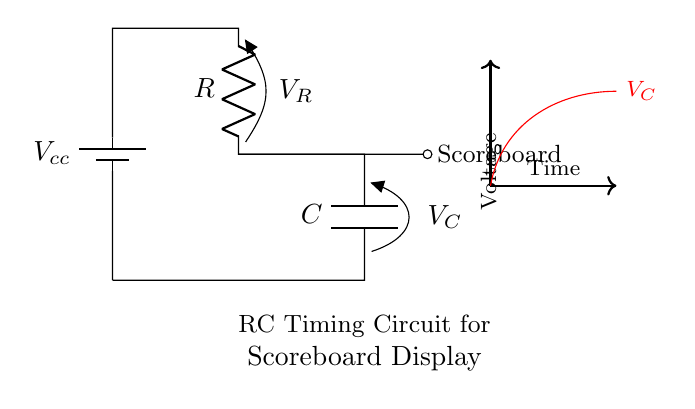What is the power supply voltage? The power supply voltage, denoted as Vcc, is usually specified alongside the battery symbol in the circuit. It represents the voltage supplied to the circuit components, ensuring proper functioning.
Answer: Vcc What components are present in the circuit? The circuit includes a battery, a resistor labeled R, and a capacitor labeled C. These components are fundamental in an RC timing circuit, which shapes the signal timing.
Answer: Battery, resistor, capacitor What is the purpose of the resistor in this circuit? The resistor in an RC timing circuit controls the charging and discharging rate of the capacitor. By placing resistance in the circuit, it creates a time constant that affects how quickly the capacitor can charge through the resistor.
Answer: Time constant What is the role of the capacitor? The capacitor in the circuit stores electrical charge and releases it over time, effectively determining the timing intervals for the scoreboard display. It works in conjunction with the resistor to establish the delay for the output signal.
Answer: Store charge If the resistor value is halved, what happens to the timing? Halving the resistor value will reduce the time constant of the RC circuit, causing the capacitor to charge and discharge more quickly, thus speeding up the response time of the scoreboard display.
Answer: Speeds up timing What happens to the scoreboard when the capacitor is fully charged? When the capacitor is fully charged, it will reach a voltage level determined by the supply voltage, and it will no longer allow current to flow through it; this results in the scoreboard maintaining its display or turning it off as per the designed logic.
Answer: Maintains display How would increasing the capacitance affect the circuit? Increasing the capacitance would increase the time constant of the RC circuit, causing the capacitor to take more time to charge and discharge, which in turn would slow down the response time of the scoreboard display.
Answer: Slows down timing 